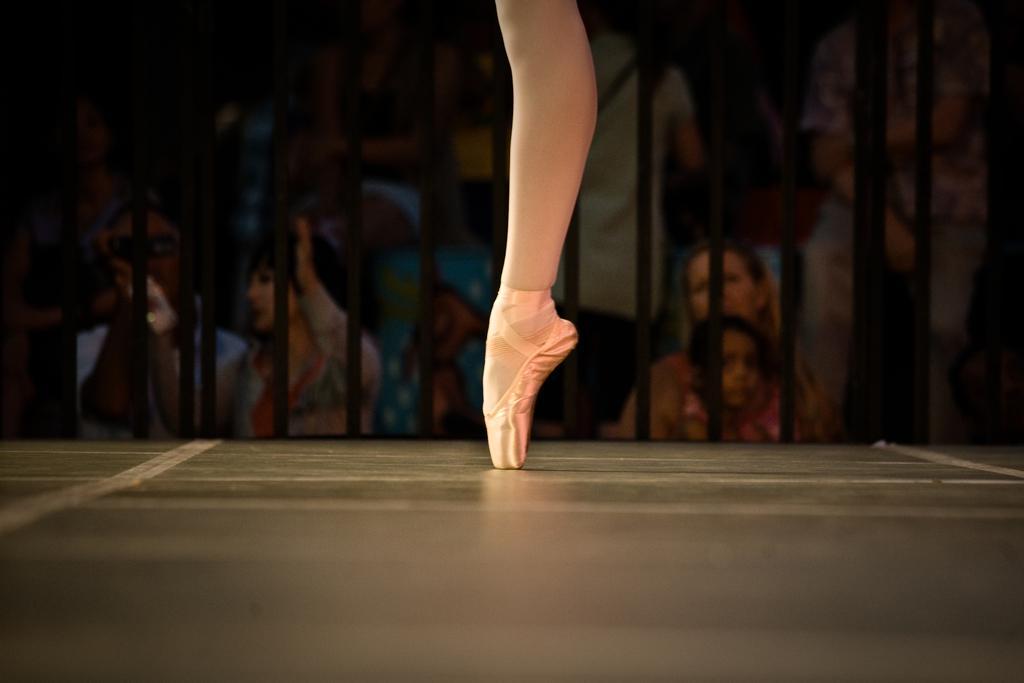Could you give a brief overview of what you see in this image? The foreground of the picture there is a stage, on the stage there is a person's leg. In the background there is railing, behind the railing there are people. The background is blurred. 